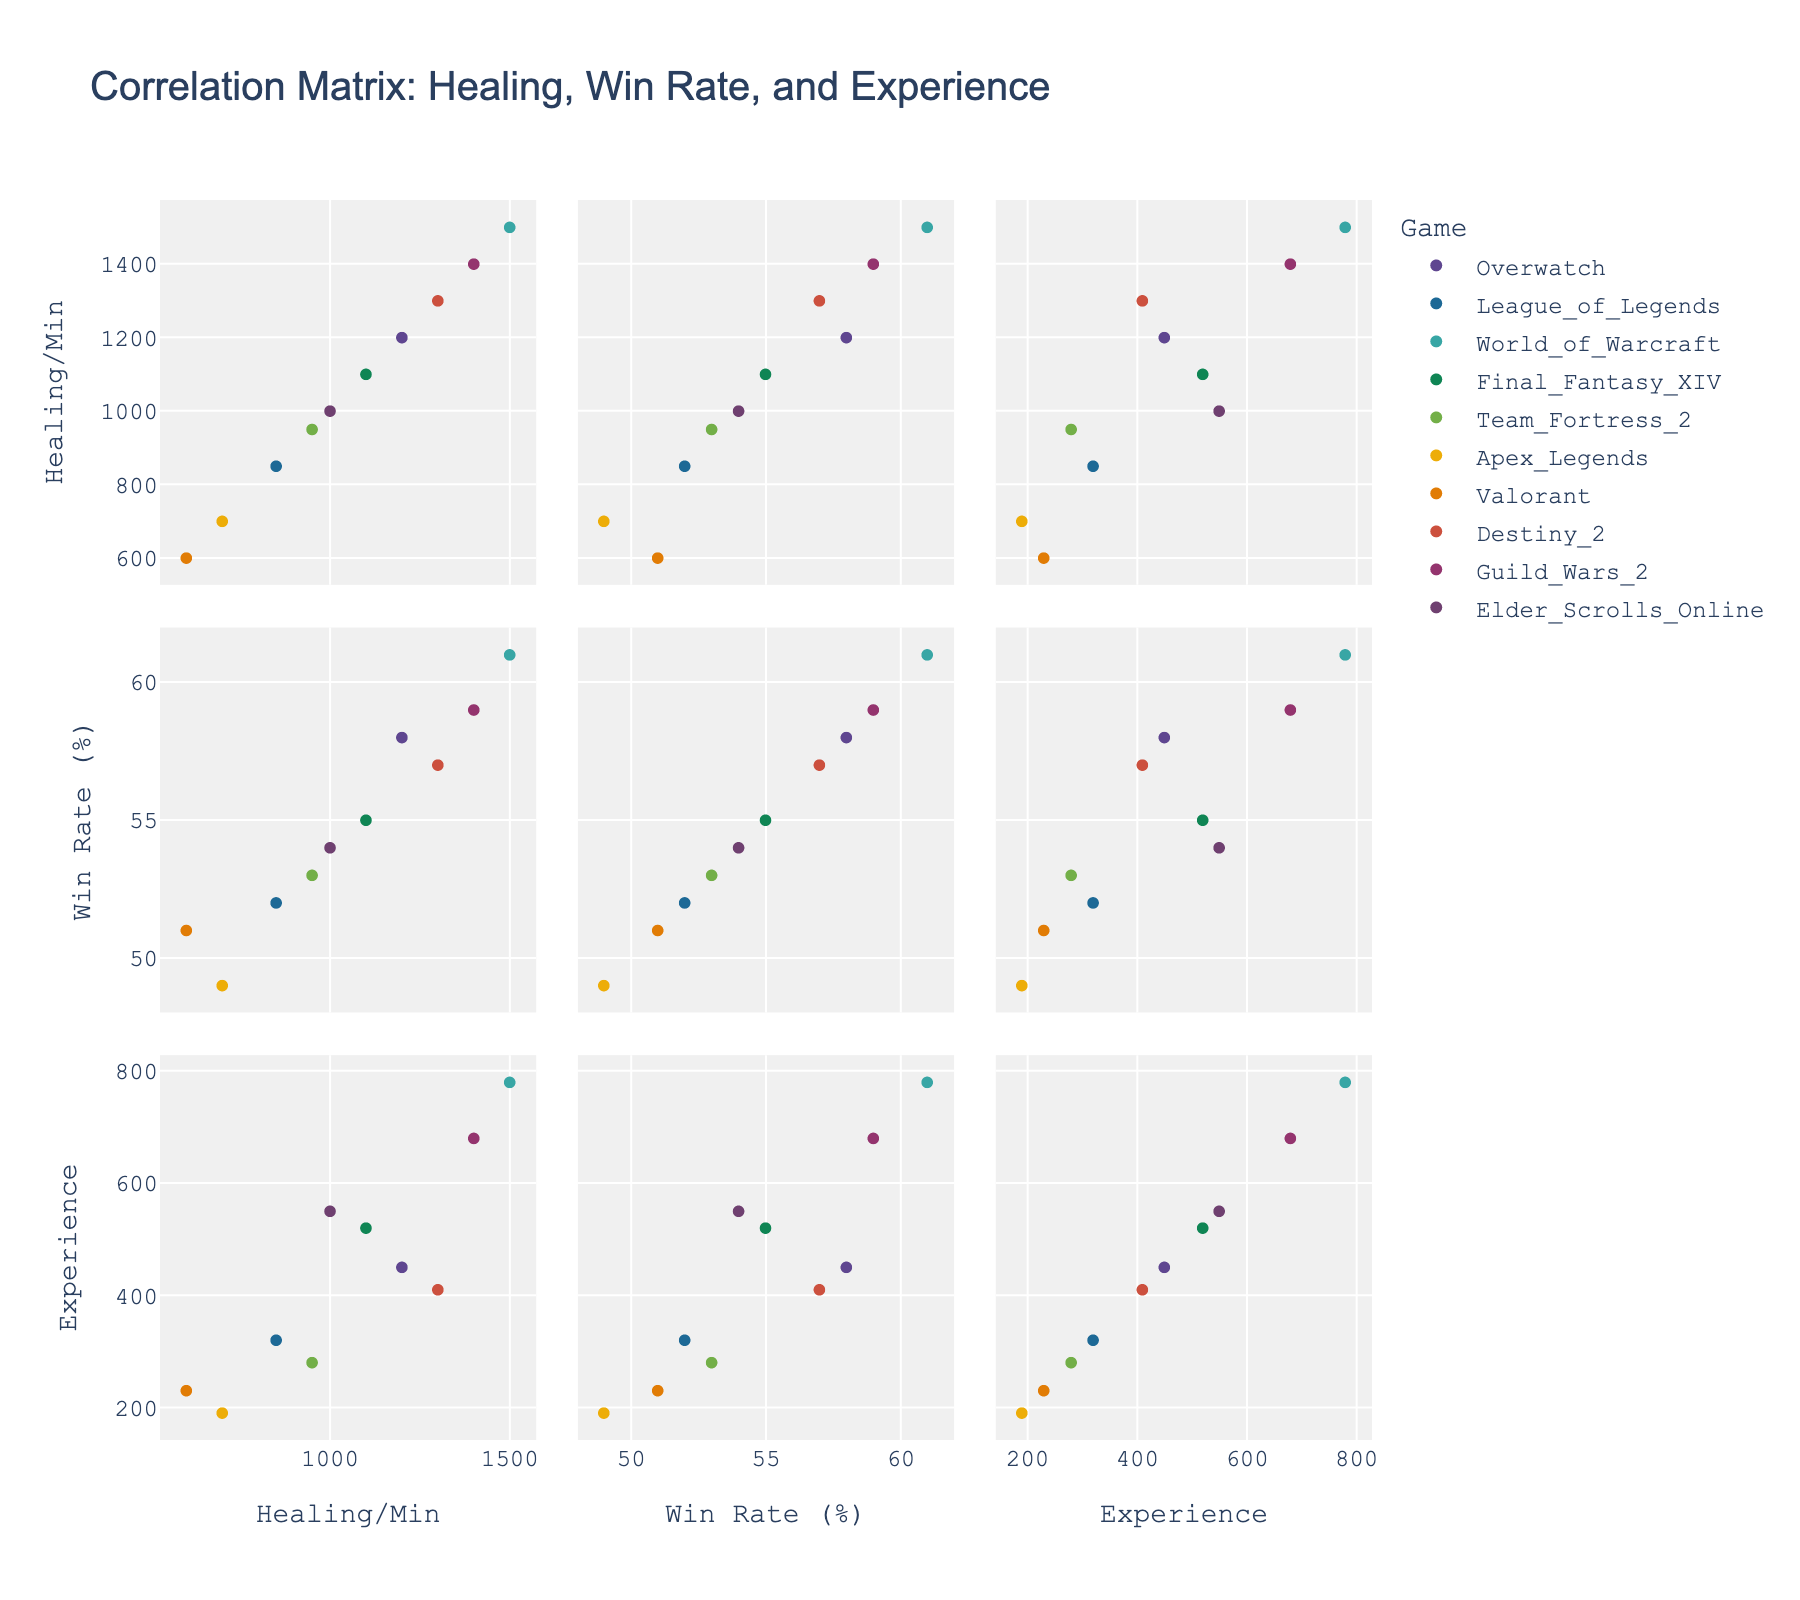What is the title of the figure? The title is typically placed at the top of the figure. In this case, it is provided in the code under the `title` parameter.
Answer: Correlation Matrix: Healing, Win Rate, and Experience How many games are represented in the scatterplot matrix? Count the number of unique games listed in the scatterplot matrix. Each data point will be labeled by game.
Answer: 10 Which game has the highest Healing_Per_Minute? Identify the data point with the highest value on the Healing_Per_Minute axis.
Answer: World_of_Warcraft Which game has the lowest Win_Rate? Identify the data point with the lowest value on the Win_Rate axis.
Answer: Apex_Legends What is the overall trend between Healing_Per_Minute and Win_Rate? Analyze the scatterplot matrix cells that compare Healing_Per_Minute and Win_Rate, looking for any upward or downward trends.
Answer: Positive correlation Does player experience level tend to correlate with higher win rates? Check the scatterplot sections that compare Player_Experience_Level with Win_Rate to determine if higher experience tends to lead to higher win rates.
Answer: Yes Which game has the highest Player Experience Level? Identify the data point with the highest value on the Player_Experience_Level axis.
Answer: World_of_Warcraft Are there any games with a Win Rate between 50% and 55%? If so, which ones? Identify the data points that fall within the specified Win Rate range.
Answer: League_of_Legends, Team_Fortress_2, Valorant, Elder_Scrolls_Online Does higher experience always result in higher Healing_Per_Minute across the games? Observe the scatterplot cells comparing Healing_Per_Minute and Player_Experience_Level to see if an increase in experience consistently relates to higher healing rates.
Answer: No Which two games have the most similar win rates? Compare the data points on the Win_Rate axis to determine which two games have the closest values.
Answer: Team_Fortress_2 and Valorant 